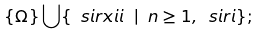Convert formula to latex. <formula><loc_0><loc_0><loc_500><loc_500>\{ \Omega \} \bigcup \{ \ s i r x i i \ | \ n \geq 1 , \ s i r i \} ;</formula> 